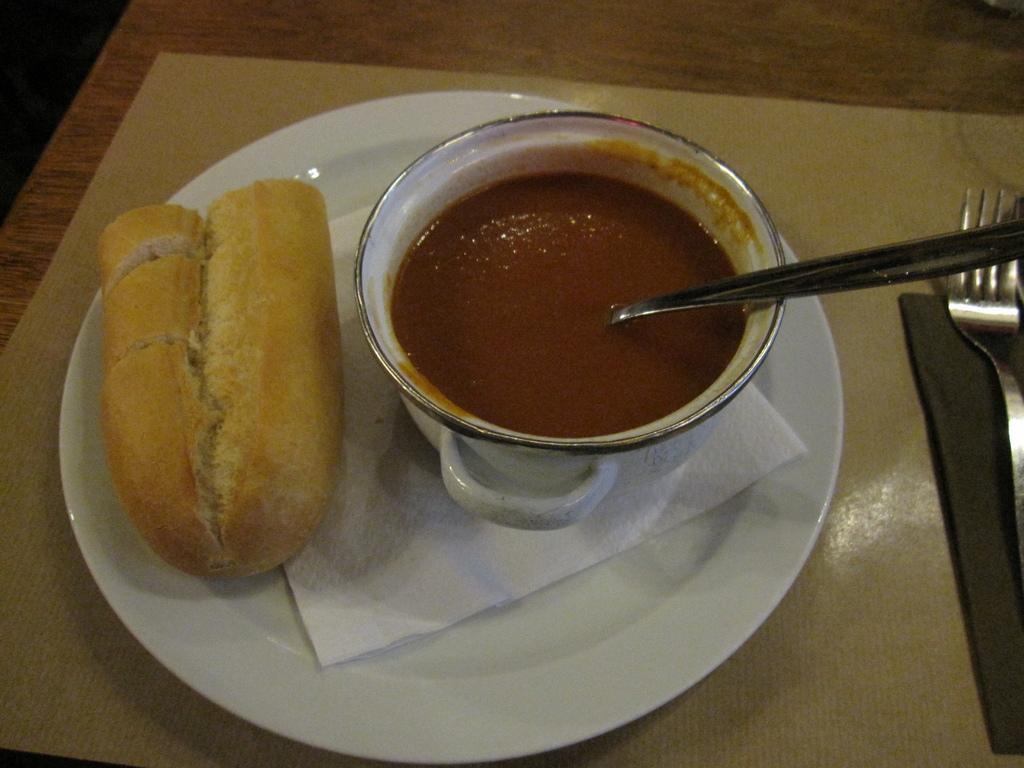Please provide a concise description of this image. This looks like a wooden table with a dining mat. I can see a plate and a fork. This plate contains tissue paper, bread and a bowl of soup. This looks like a serving spoon. 